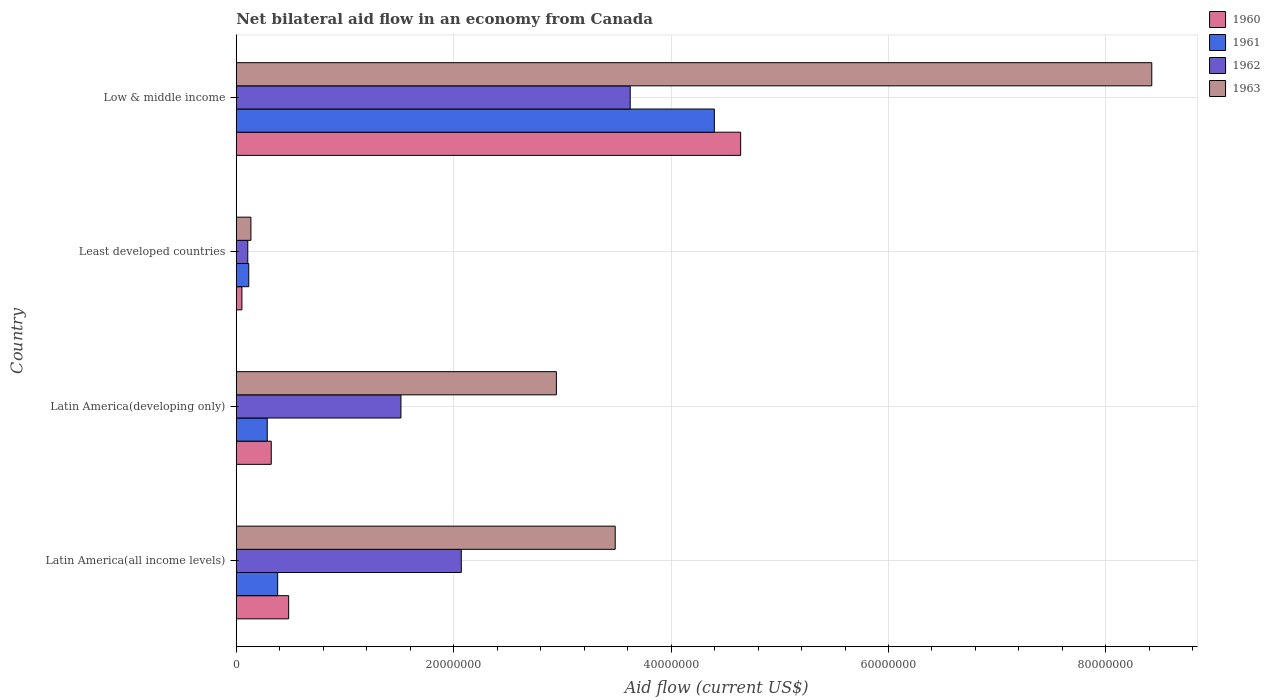How many groups of bars are there?
Make the answer very short. 4. Are the number of bars per tick equal to the number of legend labels?
Your response must be concise. Yes. Are the number of bars on each tick of the Y-axis equal?
Ensure brevity in your answer.  Yes. How many bars are there on the 3rd tick from the top?
Your answer should be compact. 4. In how many cases, is the number of bars for a given country not equal to the number of legend labels?
Offer a very short reply. 0. What is the net bilateral aid flow in 1962 in Latin America(all income levels)?
Ensure brevity in your answer.  2.07e+07. Across all countries, what is the maximum net bilateral aid flow in 1962?
Your answer should be compact. 3.62e+07. Across all countries, what is the minimum net bilateral aid flow in 1962?
Give a very brief answer. 1.06e+06. In which country was the net bilateral aid flow in 1963 maximum?
Your response must be concise. Low & middle income. In which country was the net bilateral aid flow in 1961 minimum?
Offer a terse response. Least developed countries. What is the total net bilateral aid flow in 1962 in the graph?
Make the answer very short. 7.32e+07. What is the difference between the net bilateral aid flow in 1961 in Least developed countries and that in Low & middle income?
Keep it short and to the point. -4.28e+07. What is the difference between the net bilateral aid flow in 1961 in Latin America(developing only) and the net bilateral aid flow in 1963 in Least developed countries?
Your answer should be very brief. 1.50e+06. What is the average net bilateral aid flow in 1962 per country?
Your answer should be very brief. 1.83e+07. What is the difference between the net bilateral aid flow in 1962 and net bilateral aid flow in 1960 in Latin America(all income levels)?
Your answer should be compact. 1.59e+07. In how many countries, is the net bilateral aid flow in 1963 greater than 20000000 US$?
Give a very brief answer. 3. What is the ratio of the net bilateral aid flow in 1963 in Latin America(all income levels) to that in Low & middle income?
Keep it short and to the point. 0.41. What is the difference between the highest and the second highest net bilateral aid flow in 1962?
Offer a terse response. 1.55e+07. What is the difference between the highest and the lowest net bilateral aid flow in 1960?
Offer a terse response. 4.59e+07. In how many countries, is the net bilateral aid flow in 1961 greater than the average net bilateral aid flow in 1961 taken over all countries?
Your answer should be very brief. 1. Is the sum of the net bilateral aid flow in 1960 in Latin America(developing only) and Low & middle income greater than the maximum net bilateral aid flow in 1961 across all countries?
Your answer should be compact. Yes. Is it the case that in every country, the sum of the net bilateral aid flow in 1960 and net bilateral aid flow in 1963 is greater than the sum of net bilateral aid flow in 1962 and net bilateral aid flow in 1961?
Offer a very short reply. No. What does the 3rd bar from the top in Least developed countries represents?
Keep it short and to the point. 1961. How many bars are there?
Give a very brief answer. 16. Are all the bars in the graph horizontal?
Offer a terse response. Yes. How many countries are there in the graph?
Ensure brevity in your answer.  4. What is the difference between two consecutive major ticks on the X-axis?
Provide a succinct answer. 2.00e+07. Are the values on the major ticks of X-axis written in scientific E-notation?
Give a very brief answer. No. Does the graph contain grids?
Provide a succinct answer. Yes. Where does the legend appear in the graph?
Give a very brief answer. Top right. How many legend labels are there?
Provide a succinct answer. 4. How are the legend labels stacked?
Offer a very short reply. Vertical. What is the title of the graph?
Keep it short and to the point. Net bilateral aid flow in an economy from Canada. What is the label or title of the X-axis?
Provide a short and direct response. Aid flow (current US$). What is the label or title of the Y-axis?
Keep it short and to the point. Country. What is the Aid flow (current US$) in 1960 in Latin America(all income levels)?
Provide a short and direct response. 4.82e+06. What is the Aid flow (current US$) in 1961 in Latin America(all income levels)?
Provide a succinct answer. 3.81e+06. What is the Aid flow (current US$) of 1962 in Latin America(all income levels)?
Offer a very short reply. 2.07e+07. What is the Aid flow (current US$) of 1963 in Latin America(all income levels)?
Give a very brief answer. 3.49e+07. What is the Aid flow (current US$) of 1960 in Latin America(developing only)?
Provide a succinct answer. 3.22e+06. What is the Aid flow (current US$) in 1961 in Latin America(developing only)?
Your answer should be very brief. 2.85e+06. What is the Aid flow (current US$) in 1962 in Latin America(developing only)?
Your answer should be compact. 1.52e+07. What is the Aid flow (current US$) of 1963 in Latin America(developing only)?
Provide a short and direct response. 2.94e+07. What is the Aid flow (current US$) of 1960 in Least developed countries?
Keep it short and to the point. 5.20e+05. What is the Aid flow (current US$) in 1961 in Least developed countries?
Make the answer very short. 1.15e+06. What is the Aid flow (current US$) of 1962 in Least developed countries?
Your answer should be compact. 1.06e+06. What is the Aid flow (current US$) of 1963 in Least developed countries?
Provide a short and direct response. 1.35e+06. What is the Aid flow (current US$) of 1960 in Low & middle income?
Provide a succinct answer. 4.64e+07. What is the Aid flow (current US$) of 1961 in Low & middle income?
Keep it short and to the point. 4.40e+07. What is the Aid flow (current US$) in 1962 in Low & middle income?
Your answer should be very brief. 3.62e+07. What is the Aid flow (current US$) of 1963 in Low & middle income?
Give a very brief answer. 8.42e+07. Across all countries, what is the maximum Aid flow (current US$) in 1960?
Your response must be concise. 4.64e+07. Across all countries, what is the maximum Aid flow (current US$) in 1961?
Your answer should be very brief. 4.40e+07. Across all countries, what is the maximum Aid flow (current US$) in 1962?
Your answer should be very brief. 3.62e+07. Across all countries, what is the maximum Aid flow (current US$) in 1963?
Your answer should be very brief. 8.42e+07. Across all countries, what is the minimum Aid flow (current US$) of 1960?
Ensure brevity in your answer.  5.20e+05. Across all countries, what is the minimum Aid flow (current US$) in 1961?
Make the answer very short. 1.15e+06. Across all countries, what is the minimum Aid flow (current US$) of 1962?
Ensure brevity in your answer.  1.06e+06. Across all countries, what is the minimum Aid flow (current US$) in 1963?
Make the answer very short. 1.35e+06. What is the total Aid flow (current US$) in 1960 in the graph?
Keep it short and to the point. 5.50e+07. What is the total Aid flow (current US$) of 1961 in the graph?
Offer a very short reply. 5.18e+07. What is the total Aid flow (current US$) of 1962 in the graph?
Ensure brevity in your answer.  7.32e+07. What is the total Aid flow (current US$) of 1963 in the graph?
Provide a short and direct response. 1.50e+08. What is the difference between the Aid flow (current US$) of 1960 in Latin America(all income levels) and that in Latin America(developing only)?
Give a very brief answer. 1.60e+06. What is the difference between the Aid flow (current US$) in 1961 in Latin America(all income levels) and that in Latin America(developing only)?
Provide a short and direct response. 9.60e+05. What is the difference between the Aid flow (current US$) in 1962 in Latin America(all income levels) and that in Latin America(developing only)?
Provide a succinct answer. 5.55e+06. What is the difference between the Aid flow (current US$) in 1963 in Latin America(all income levels) and that in Latin America(developing only)?
Your answer should be very brief. 5.41e+06. What is the difference between the Aid flow (current US$) in 1960 in Latin America(all income levels) and that in Least developed countries?
Your answer should be very brief. 4.30e+06. What is the difference between the Aid flow (current US$) in 1961 in Latin America(all income levels) and that in Least developed countries?
Provide a short and direct response. 2.66e+06. What is the difference between the Aid flow (current US$) in 1962 in Latin America(all income levels) and that in Least developed countries?
Give a very brief answer. 1.96e+07. What is the difference between the Aid flow (current US$) of 1963 in Latin America(all income levels) and that in Least developed countries?
Your answer should be very brief. 3.35e+07. What is the difference between the Aid flow (current US$) in 1960 in Latin America(all income levels) and that in Low & middle income?
Ensure brevity in your answer.  -4.16e+07. What is the difference between the Aid flow (current US$) in 1961 in Latin America(all income levels) and that in Low & middle income?
Provide a succinct answer. -4.02e+07. What is the difference between the Aid flow (current US$) of 1962 in Latin America(all income levels) and that in Low & middle income?
Ensure brevity in your answer.  -1.55e+07. What is the difference between the Aid flow (current US$) of 1963 in Latin America(all income levels) and that in Low & middle income?
Your answer should be compact. -4.94e+07. What is the difference between the Aid flow (current US$) of 1960 in Latin America(developing only) and that in Least developed countries?
Offer a very short reply. 2.70e+06. What is the difference between the Aid flow (current US$) of 1961 in Latin America(developing only) and that in Least developed countries?
Provide a succinct answer. 1.70e+06. What is the difference between the Aid flow (current US$) in 1962 in Latin America(developing only) and that in Least developed countries?
Make the answer very short. 1.41e+07. What is the difference between the Aid flow (current US$) of 1963 in Latin America(developing only) and that in Least developed countries?
Provide a short and direct response. 2.81e+07. What is the difference between the Aid flow (current US$) in 1960 in Latin America(developing only) and that in Low & middle income?
Your answer should be very brief. -4.32e+07. What is the difference between the Aid flow (current US$) in 1961 in Latin America(developing only) and that in Low & middle income?
Your response must be concise. -4.11e+07. What is the difference between the Aid flow (current US$) of 1962 in Latin America(developing only) and that in Low & middle income?
Your response must be concise. -2.11e+07. What is the difference between the Aid flow (current US$) of 1963 in Latin America(developing only) and that in Low & middle income?
Your response must be concise. -5.48e+07. What is the difference between the Aid flow (current US$) in 1960 in Least developed countries and that in Low & middle income?
Offer a terse response. -4.59e+07. What is the difference between the Aid flow (current US$) in 1961 in Least developed countries and that in Low & middle income?
Provide a succinct answer. -4.28e+07. What is the difference between the Aid flow (current US$) of 1962 in Least developed countries and that in Low & middle income?
Your answer should be compact. -3.52e+07. What is the difference between the Aid flow (current US$) of 1963 in Least developed countries and that in Low & middle income?
Give a very brief answer. -8.29e+07. What is the difference between the Aid flow (current US$) of 1960 in Latin America(all income levels) and the Aid flow (current US$) of 1961 in Latin America(developing only)?
Make the answer very short. 1.97e+06. What is the difference between the Aid flow (current US$) in 1960 in Latin America(all income levels) and the Aid flow (current US$) in 1962 in Latin America(developing only)?
Make the answer very short. -1.03e+07. What is the difference between the Aid flow (current US$) of 1960 in Latin America(all income levels) and the Aid flow (current US$) of 1963 in Latin America(developing only)?
Give a very brief answer. -2.46e+07. What is the difference between the Aid flow (current US$) in 1961 in Latin America(all income levels) and the Aid flow (current US$) in 1962 in Latin America(developing only)?
Make the answer very short. -1.13e+07. What is the difference between the Aid flow (current US$) in 1961 in Latin America(all income levels) and the Aid flow (current US$) in 1963 in Latin America(developing only)?
Your answer should be very brief. -2.56e+07. What is the difference between the Aid flow (current US$) of 1962 in Latin America(all income levels) and the Aid flow (current US$) of 1963 in Latin America(developing only)?
Give a very brief answer. -8.75e+06. What is the difference between the Aid flow (current US$) of 1960 in Latin America(all income levels) and the Aid flow (current US$) of 1961 in Least developed countries?
Provide a short and direct response. 3.67e+06. What is the difference between the Aid flow (current US$) of 1960 in Latin America(all income levels) and the Aid flow (current US$) of 1962 in Least developed countries?
Your answer should be compact. 3.76e+06. What is the difference between the Aid flow (current US$) in 1960 in Latin America(all income levels) and the Aid flow (current US$) in 1963 in Least developed countries?
Your answer should be very brief. 3.47e+06. What is the difference between the Aid flow (current US$) in 1961 in Latin America(all income levels) and the Aid flow (current US$) in 1962 in Least developed countries?
Your response must be concise. 2.75e+06. What is the difference between the Aid flow (current US$) in 1961 in Latin America(all income levels) and the Aid flow (current US$) in 1963 in Least developed countries?
Keep it short and to the point. 2.46e+06. What is the difference between the Aid flow (current US$) in 1962 in Latin America(all income levels) and the Aid flow (current US$) in 1963 in Least developed countries?
Ensure brevity in your answer.  1.94e+07. What is the difference between the Aid flow (current US$) in 1960 in Latin America(all income levels) and the Aid flow (current US$) in 1961 in Low & middle income?
Your response must be concise. -3.92e+07. What is the difference between the Aid flow (current US$) in 1960 in Latin America(all income levels) and the Aid flow (current US$) in 1962 in Low & middle income?
Provide a short and direct response. -3.14e+07. What is the difference between the Aid flow (current US$) in 1960 in Latin America(all income levels) and the Aid flow (current US$) in 1963 in Low & middle income?
Your answer should be very brief. -7.94e+07. What is the difference between the Aid flow (current US$) of 1961 in Latin America(all income levels) and the Aid flow (current US$) of 1962 in Low & middle income?
Offer a very short reply. -3.24e+07. What is the difference between the Aid flow (current US$) of 1961 in Latin America(all income levels) and the Aid flow (current US$) of 1963 in Low & middle income?
Keep it short and to the point. -8.04e+07. What is the difference between the Aid flow (current US$) in 1962 in Latin America(all income levels) and the Aid flow (current US$) in 1963 in Low & middle income?
Provide a succinct answer. -6.35e+07. What is the difference between the Aid flow (current US$) of 1960 in Latin America(developing only) and the Aid flow (current US$) of 1961 in Least developed countries?
Your answer should be compact. 2.07e+06. What is the difference between the Aid flow (current US$) of 1960 in Latin America(developing only) and the Aid flow (current US$) of 1962 in Least developed countries?
Ensure brevity in your answer.  2.16e+06. What is the difference between the Aid flow (current US$) in 1960 in Latin America(developing only) and the Aid flow (current US$) in 1963 in Least developed countries?
Offer a very short reply. 1.87e+06. What is the difference between the Aid flow (current US$) of 1961 in Latin America(developing only) and the Aid flow (current US$) of 1962 in Least developed countries?
Your response must be concise. 1.79e+06. What is the difference between the Aid flow (current US$) of 1961 in Latin America(developing only) and the Aid flow (current US$) of 1963 in Least developed countries?
Make the answer very short. 1.50e+06. What is the difference between the Aid flow (current US$) of 1962 in Latin America(developing only) and the Aid flow (current US$) of 1963 in Least developed countries?
Make the answer very short. 1.38e+07. What is the difference between the Aid flow (current US$) in 1960 in Latin America(developing only) and the Aid flow (current US$) in 1961 in Low & middle income?
Make the answer very short. -4.08e+07. What is the difference between the Aid flow (current US$) in 1960 in Latin America(developing only) and the Aid flow (current US$) in 1962 in Low & middle income?
Offer a very short reply. -3.30e+07. What is the difference between the Aid flow (current US$) of 1960 in Latin America(developing only) and the Aid flow (current US$) of 1963 in Low & middle income?
Give a very brief answer. -8.10e+07. What is the difference between the Aid flow (current US$) of 1961 in Latin America(developing only) and the Aid flow (current US$) of 1962 in Low & middle income?
Keep it short and to the point. -3.34e+07. What is the difference between the Aid flow (current US$) of 1961 in Latin America(developing only) and the Aid flow (current US$) of 1963 in Low & middle income?
Offer a terse response. -8.14e+07. What is the difference between the Aid flow (current US$) of 1962 in Latin America(developing only) and the Aid flow (current US$) of 1963 in Low & middle income?
Keep it short and to the point. -6.91e+07. What is the difference between the Aid flow (current US$) of 1960 in Least developed countries and the Aid flow (current US$) of 1961 in Low & middle income?
Offer a terse response. -4.35e+07. What is the difference between the Aid flow (current US$) of 1960 in Least developed countries and the Aid flow (current US$) of 1962 in Low & middle income?
Your answer should be compact. -3.57e+07. What is the difference between the Aid flow (current US$) in 1960 in Least developed countries and the Aid flow (current US$) in 1963 in Low & middle income?
Give a very brief answer. -8.37e+07. What is the difference between the Aid flow (current US$) in 1961 in Least developed countries and the Aid flow (current US$) in 1962 in Low & middle income?
Provide a short and direct response. -3.51e+07. What is the difference between the Aid flow (current US$) in 1961 in Least developed countries and the Aid flow (current US$) in 1963 in Low & middle income?
Provide a succinct answer. -8.31e+07. What is the difference between the Aid flow (current US$) of 1962 in Least developed countries and the Aid flow (current US$) of 1963 in Low & middle income?
Provide a succinct answer. -8.32e+07. What is the average Aid flow (current US$) of 1960 per country?
Your answer should be very brief. 1.37e+07. What is the average Aid flow (current US$) of 1961 per country?
Your answer should be very brief. 1.29e+07. What is the average Aid flow (current US$) in 1962 per country?
Offer a terse response. 1.83e+07. What is the average Aid flow (current US$) of 1963 per country?
Ensure brevity in your answer.  3.75e+07. What is the difference between the Aid flow (current US$) in 1960 and Aid flow (current US$) in 1961 in Latin America(all income levels)?
Provide a succinct answer. 1.01e+06. What is the difference between the Aid flow (current US$) of 1960 and Aid flow (current US$) of 1962 in Latin America(all income levels)?
Provide a short and direct response. -1.59e+07. What is the difference between the Aid flow (current US$) in 1960 and Aid flow (current US$) in 1963 in Latin America(all income levels)?
Offer a very short reply. -3.00e+07. What is the difference between the Aid flow (current US$) in 1961 and Aid flow (current US$) in 1962 in Latin America(all income levels)?
Keep it short and to the point. -1.69e+07. What is the difference between the Aid flow (current US$) of 1961 and Aid flow (current US$) of 1963 in Latin America(all income levels)?
Provide a short and direct response. -3.10e+07. What is the difference between the Aid flow (current US$) in 1962 and Aid flow (current US$) in 1963 in Latin America(all income levels)?
Offer a very short reply. -1.42e+07. What is the difference between the Aid flow (current US$) in 1960 and Aid flow (current US$) in 1961 in Latin America(developing only)?
Give a very brief answer. 3.70e+05. What is the difference between the Aid flow (current US$) in 1960 and Aid flow (current US$) in 1962 in Latin America(developing only)?
Make the answer very short. -1.19e+07. What is the difference between the Aid flow (current US$) in 1960 and Aid flow (current US$) in 1963 in Latin America(developing only)?
Provide a succinct answer. -2.62e+07. What is the difference between the Aid flow (current US$) of 1961 and Aid flow (current US$) of 1962 in Latin America(developing only)?
Your response must be concise. -1.23e+07. What is the difference between the Aid flow (current US$) of 1961 and Aid flow (current US$) of 1963 in Latin America(developing only)?
Offer a terse response. -2.66e+07. What is the difference between the Aid flow (current US$) in 1962 and Aid flow (current US$) in 1963 in Latin America(developing only)?
Ensure brevity in your answer.  -1.43e+07. What is the difference between the Aid flow (current US$) of 1960 and Aid flow (current US$) of 1961 in Least developed countries?
Give a very brief answer. -6.30e+05. What is the difference between the Aid flow (current US$) of 1960 and Aid flow (current US$) of 1962 in Least developed countries?
Provide a short and direct response. -5.40e+05. What is the difference between the Aid flow (current US$) of 1960 and Aid flow (current US$) of 1963 in Least developed countries?
Offer a terse response. -8.30e+05. What is the difference between the Aid flow (current US$) in 1960 and Aid flow (current US$) in 1961 in Low & middle income?
Ensure brevity in your answer.  2.42e+06. What is the difference between the Aid flow (current US$) in 1960 and Aid flow (current US$) in 1962 in Low & middle income?
Offer a very short reply. 1.02e+07. What is the difference between the Aid flow (current US$) in 1960 and Aid flow (current US$) in 1963 in Low & middle income?
Your answer should be very brief. -3.78e+07. What is the difference between the Aid flow (current US$) in 1961 and Aid flow (current US$) in 1962 in Low & middle income?
Ensure brevity in your answer.  7.74e+06. What is the difference between the Aid flow (current US$) of 1961 and Aid flow (current US$) of 1963 in Low & middle income?
Ensure brevity in your answer.  -4.02e+07. What is the difference between the Aid flow (current US$) of 1962 and Aid flow (current US$) of 1963 in Low & middle income?
Your response must be concise. -4.80e+07. What is the ratio of the Aid flow (current US$) of 1960 in Latin America(all income levels) to that in Latin America(developing only)?
Your answer should be very brief. 1.5. What is the ratio of the Aid flow (current US$) of 1961 in Latin America(all income levels) to that in Latin America(developing only)?
Your answer should be very brief. 1.34. What is the ratio of the Aid flow (current US$) in 1962 in Latin America(all income levels) to that in Latin America(developing only)?
Offer a terse response. 1.37. What is the ratio of the Aid flow (current US$) in 1963 in Latin America(all income levels) to that in Latin America(developing only)?
Ensure brevity in your answer.  1.18. What is the ratio of the Aid flow (current US$) of 1960 in Latin America(all income levels) to that in Least developed countries?
Make the answer very short. 9.27. What is the ratio of the Aid flow (current US$) in 1961 in Latin America(all income levels) to that in Least developed countries?
Make the answer very short. 3.31. What is the ratio of the Aid flow (current US$) of 1962 in Latin America(all income levels) to that in Least developed countries?
Your response must be concise. 19.53. What is the ratio of the Aid flow (current US$) in 1963 in Latin America(all income levels) to that in Least developed countries?
Ensure brevity in your answer.  25.82. What is the ratio of the Aid flow (current US$) of 1960 in Latin America(all income levels) to that in Low & middle income?
Your response must be concise. 0.1. What is the ratio of the Aid flow (current US$) in 1961 in Latin America(all income levels) to that in Low & middle income?
Offer a terse response. 0.09. What is the ratio of the Aid flow (current US$) of 1962 in Latin America(all income levels) to that in Low & middle income?
Offer a terse response. 0.57. What is the ratio of the Aid flow (current US$) in 1963 in Latin America(all income levels) to that in Low & middle income?
Your answer should be compact. 0.41. What is the ratio of the Aid flow (current US$) in 1960 in Latin America(developing only) to that in Least developed countries?
Provide a succinct answer. 6.19. What is the ratio of the Aid flow (current US$) in 1961 in Latin America(developing only) to that in Least developed countries?
Provide a short and direct response. 2.48. What is the ratio of the Aid flow (current US$) in 1962 in Latin America(developing only) to that in Least developed countries?
Offer a very short reply. 14.29. What is the ratio of the Aid flow (current US$) of 1963 in Latin America(developing only) to that in Least developed countries?
Keep it short and to the point. 21.81. What is the ratio of the Aid flow (current US$) of 1960 in Latin America(developing only) to that in Low & middle income?
Give a very brief answer. 0.07. What is the ratio of the Aid flow (current US$) in 1961 in Latin America(developing only) to that in Low & middle income?
Make the answer very short. 0.06. What is the ratio of the Aid flow (current US$) of 1962 in Latin America(developing only) to that in Low & middle income?
Provide a succinct answer. 0.42. What is the ratio of the Aid flow (current US$) of 1963 in Latin America(developing only) to that in Low & middle income?
Your response must be concise. 0.35. What is the ratio of the Aid flow (current US$) in 1960 in Least developed countries to that in Low & middle income?
Make the answer very short. 0.01. What is the ratio of the Aid flow (current US$) in 1961 in Least developed countries to that in Low & middle income?
Offer a very short reply. 0.03. What is the ratio of the Aid flow (current US$) in 1962 in Least developed countries to that in Low & middle income?
Your answer should be very brief. 0.03. What is the ratio of the Aid flow (current US$) in 1963 in Least developed countries to that in Low & middle income?
Make the answer very short. 0.02. What is the difference between the highest and the second highest Aid flow (current US$) of 1960?
Provide a short and direct response. 4.16e+07. What is the difference between the highest and the second highest Aid flow (current US$) of 1961?
Make the answer very short. 4.02e+07. What is the difference between the highest and the second highest Aid flow (current US$) of 1962?
Keep it short and to the point. 1.55e+07. What is the difference between the highest and the second highest Aid flow (current US$) in 1963?
Keep it short and to the point. 4.94e+07. What is the difference between the highest and the lowest Aid flow (current US$) of 1960?
Keep it short and to the point. 4.59e+07. What is the difference between the highest and the lowest Aid flow (current US$) in 1961?
Provide a succinct answer. 4.28e+07. What is the difference between the highest and the lowest Aid flow (current US$) of 1962?
Keep it short and to the point. 3.52e+07. What is the difference between the highest and the lowest Aid flow (current US$) in 1963?
Make the answer very short. 8.29e+07. 